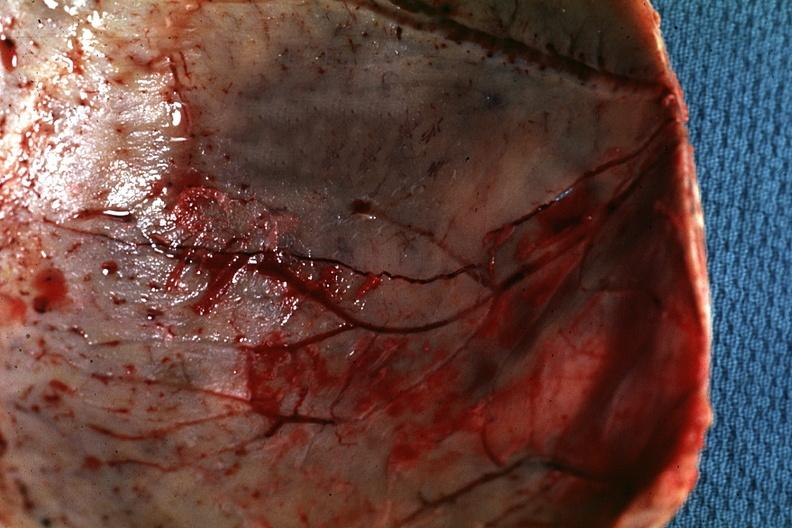s fracture present?
Answer the question using a single word or phrase. Yes 